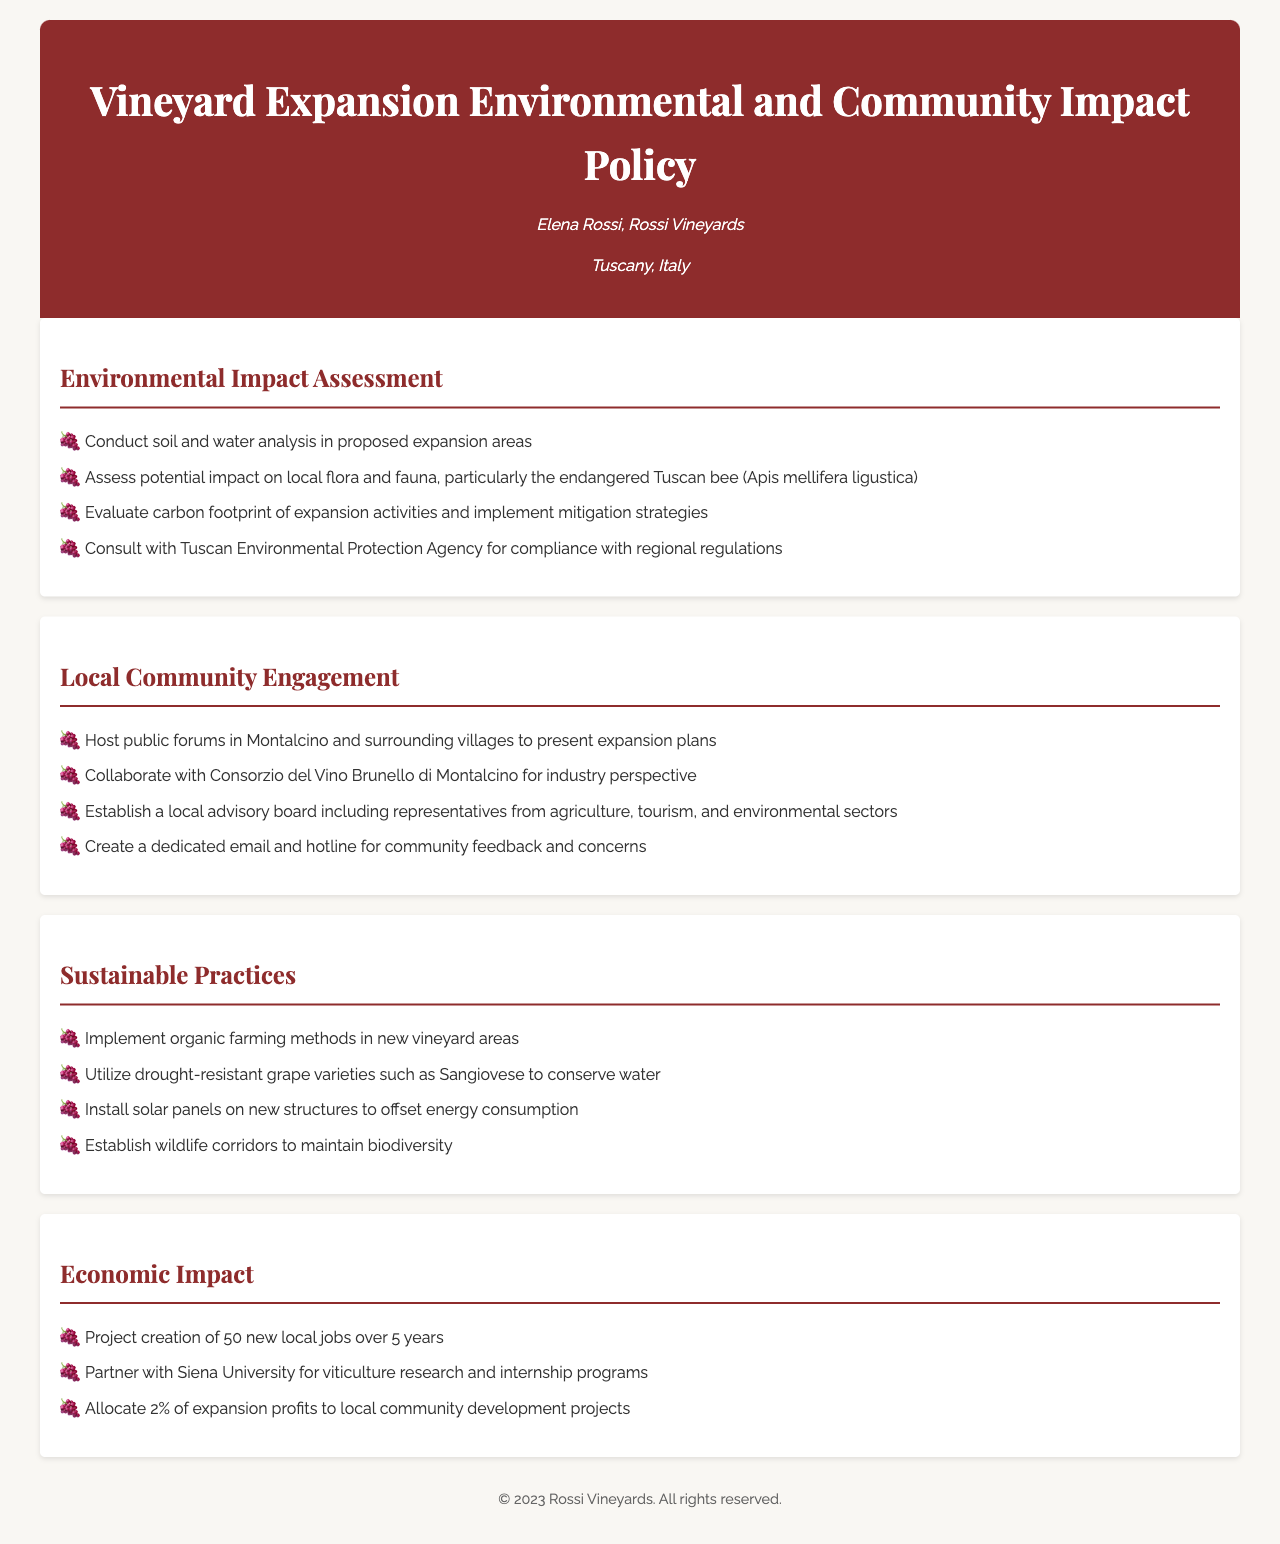What is the specific bee species mentioned in the document? The document refers to the endangered Tuscan bee, highlighting its importance for local biodiversity.
Answer: Tuscan bee How many local jobs are projected to be created over 5 years? The document states that the projection involves creating local jobs, quantifying the impact of the vineyard expansion.
Answer: 50 What type of farming methods will be implemented in new vineyard areas? Organic farming methods are highlighted as part of the sustainable practices section, indicating a commitment to environmentally friendly methods.
Answer: Organic farming Which university is mentioned for collaboration on viticulture research? The document mentions partnering with a university for research and internship programs, emphasizing educational collaboration.
Answer: Siena University What is one method to be used for conserving water? The document outlines the use of drought-resistant grape varieties as a key strategy for conserving water resources during vineyard expansion.
Answer: Drought-resistant grape varieties 